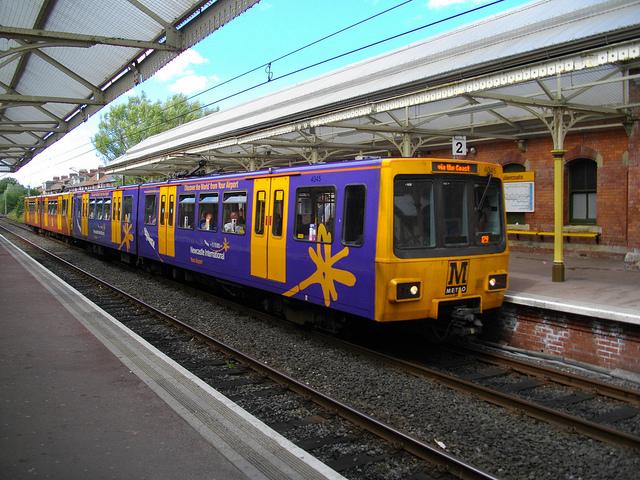What colors is the train?
Keep it brief. Purple and yellow. What color is the front of the train?
Give a very brief answer. Yellow. Is the train crowded?
Concise answer only. No. Which direction is this train going?
Concise answer only. Right. Is this train moving?
Quick response, please. No. What time of day is it?
Concise answer only. Morning. Is this a cargo train?
Give a very brief answer. No. 